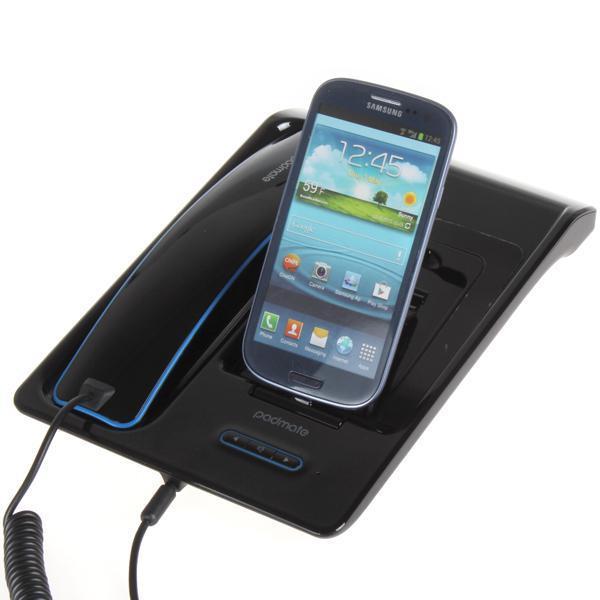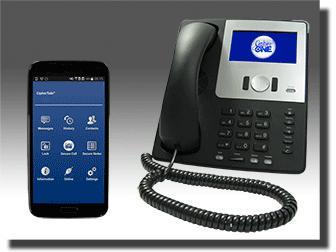The first image is the image on the left, the second image is the image on the right. Assess this claim about the two images: "One of the images shows a cell phone docked on a landline phone base.". Correct or not? Answer yes or no. Yes. The first image is the image on the left, the second image is the image on the right. Assess this claim about the two images: "There are exactly two phones in the right image.". Correct or not? Answer yes or no. Yes. 